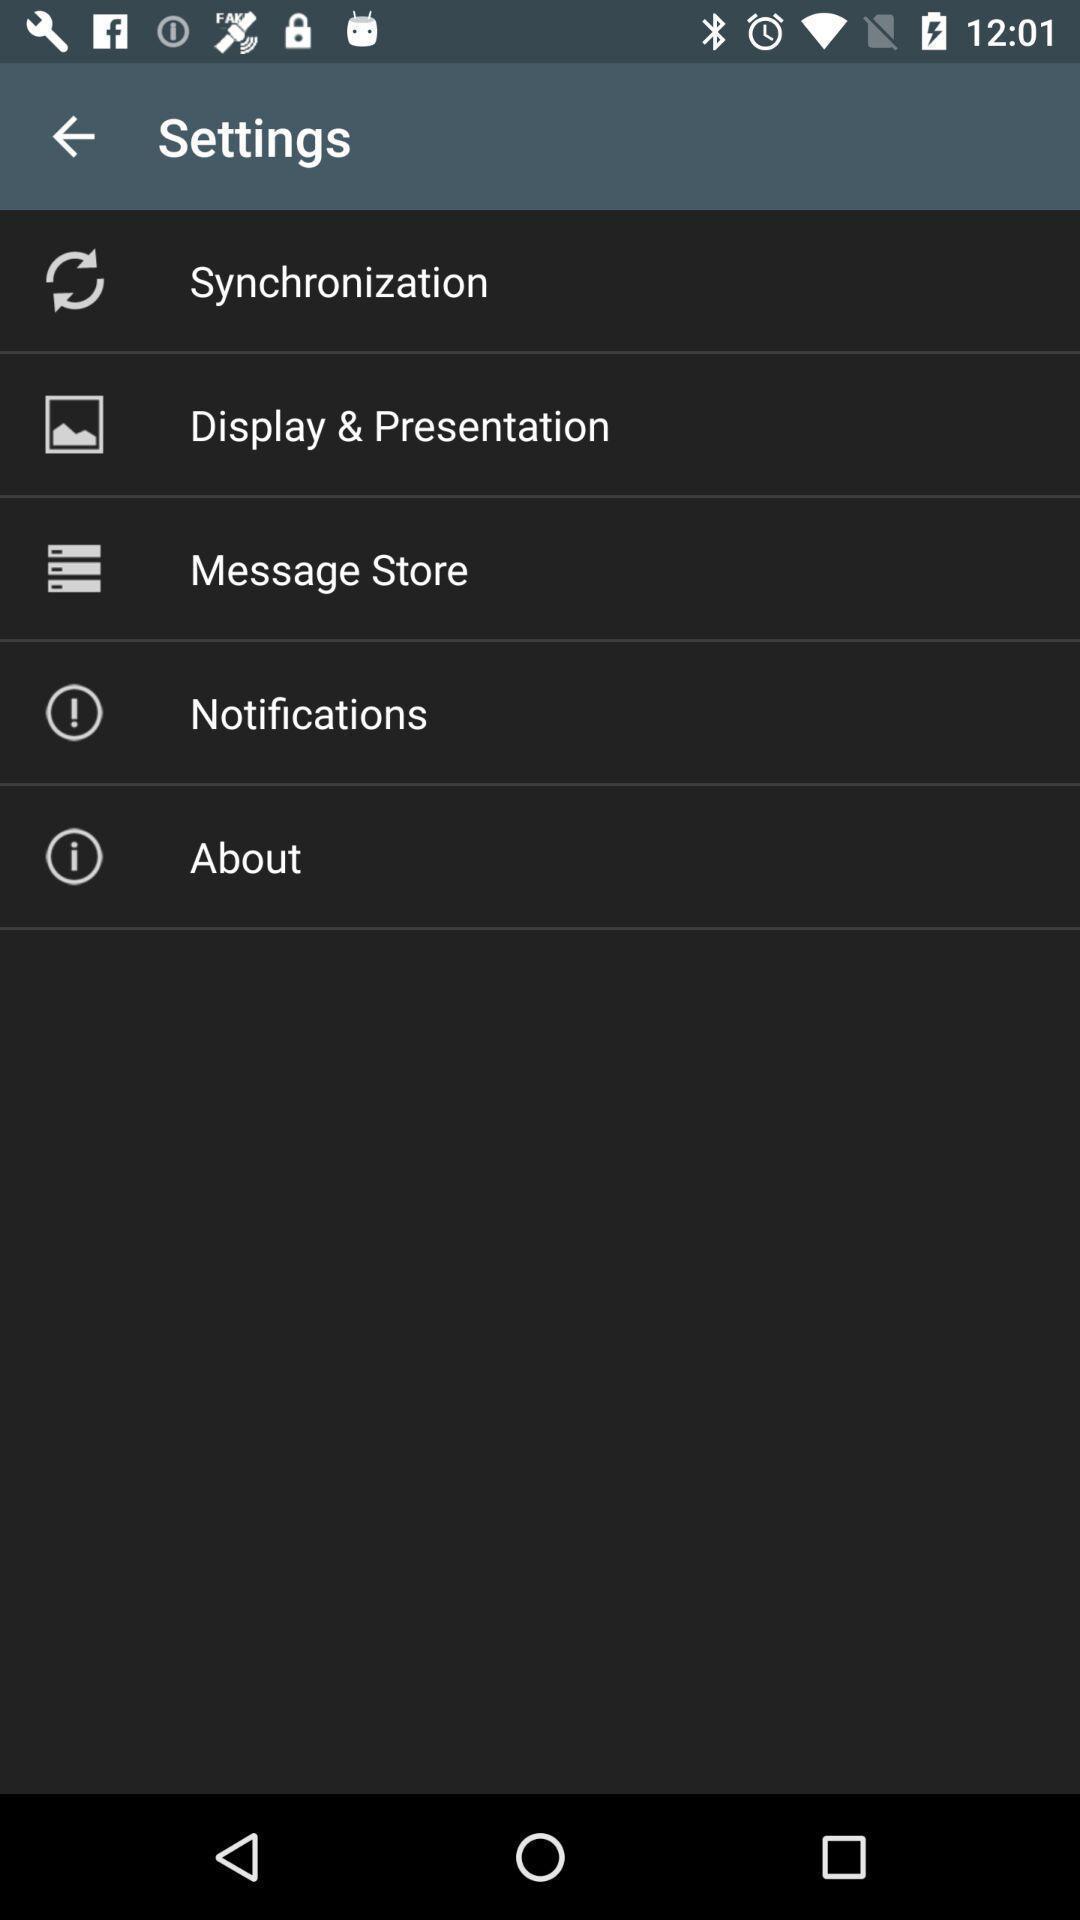Provide a textual representation of this image. Settings page. 